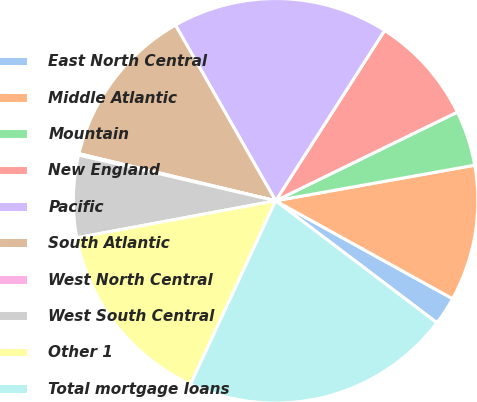Convert chart. <chart><loc_0><loc_0><loc_500><loc_500><pie_chart><fcel>East North Central<fcel>Middle Atlantic<fcel>Mountain<fcel>New England<fcel>Pacific<fcel>South Atlantic<fcel>West North Central<fcel>West South Central<fcel>Other 1<fcel>Total mortgage loans<nl><fcel>2.26%<fcel>10.86%<fcel>4.41%<fcel>8.71%<fcel>17.31%<fcel>13.01%<fcel>0.11%<fcel>6.56%<fcel>15.16%<fcel>21.61%<nl></chart> 